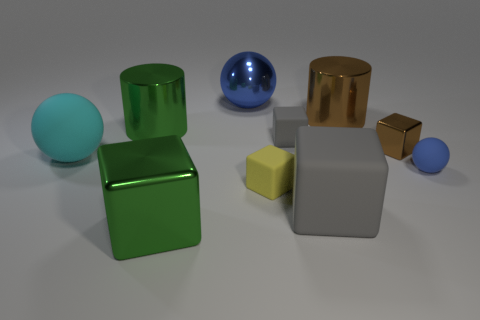Subtract all green cubes. How many cubes are left? 4 Subtract all brown cylinders. How many cylinders are left? 1 Subtract all spheres. How many objects are left? 7 Subtract 2 balls. How many balls are left? 1 Subtract all red cylinders. How many blue spheres are left? 2 Subtract all blue objects. Subtract all big blue things. How many objects are left? 7 Add 4 big gray matte things. How many big gray matte things are left? 5 Add 6 big gray blocks. How many big gray blocks exist? 7 Subtract 2 gray blocks. How many objects are left? 8 Subtract all yellow balls. Subtract all purple blocks. How many balls are left? 3 